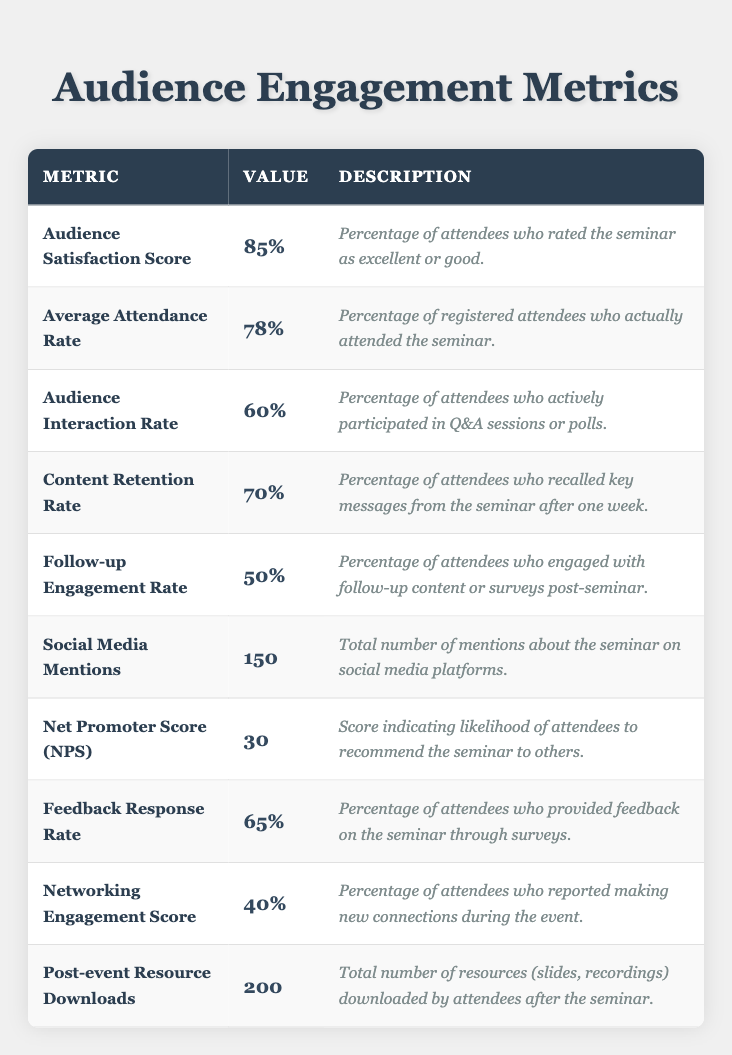What is the Audience Satisfaction Score? The table displays the Audience Satisfaction Score as 85%, which is the value assigned to this metric.
Answer: 85% What percentage of registered attendees attended the seminar? The metric for the Average Attendance Rate indicates that 78% of registered attendees actually attended the seminar.
Answer: 78% How many social media mentions were there? The Social Media Mentions metric shows a total of 150 mentions about the seminar.
Answer: 150 What is the Content Retention Rate? The Content Retention Rate is indicated as 70%, reflecting the percentage of attendees who recalled key messages after one week.
Answer: 70% What percentage of attendees actively participated in Q&A sessions or polls? According to the Audience Interaction Rate, 60% of attendees actively participated in these sessions.
Answer: 60% Is the Follow-up Engagement Rate greater than the Networking Engagement Score? The Follow-up Engagement Rate is 50% while the Networking Engagement Score is 40%, making the Follow-up Engagement Rate greater.
Answer: Yes What is the difference between the Audience Satisfaction Score and the Follow-up Engagement Rate? The Audience Satisfaction Score is 85% and the Follow-up Engagement Rate is 50%. The difference is 85 - 50 = 35%.
Answer: 35% What is the median of the Audience Engagement metrics values provided? The metrics values (85, 78, 60, 70, 50, 150, 30, 65, 40, 200) can be arranged in order: 30, 40, 50, 60, 65, 70, 78, 85, 150, 200. The median is the average of the 5th and 6th values: (70 + 78)/2 = 74.
Answer: 74 What percentage of attendees provided feedback through surveys? The Feedback Response Rate shows that 65% of attendees provided feedback on the seminar.
Answer: 65% How many attendees were engaged with follow-up content compared to those who made new connections during the event? The Follow-up Engagement Rate is 50% and the Networking Engagement Score is 40%. Comparing these shows that more attendees engaged with follow-up content.
Answer: More engaged with follow-up content 